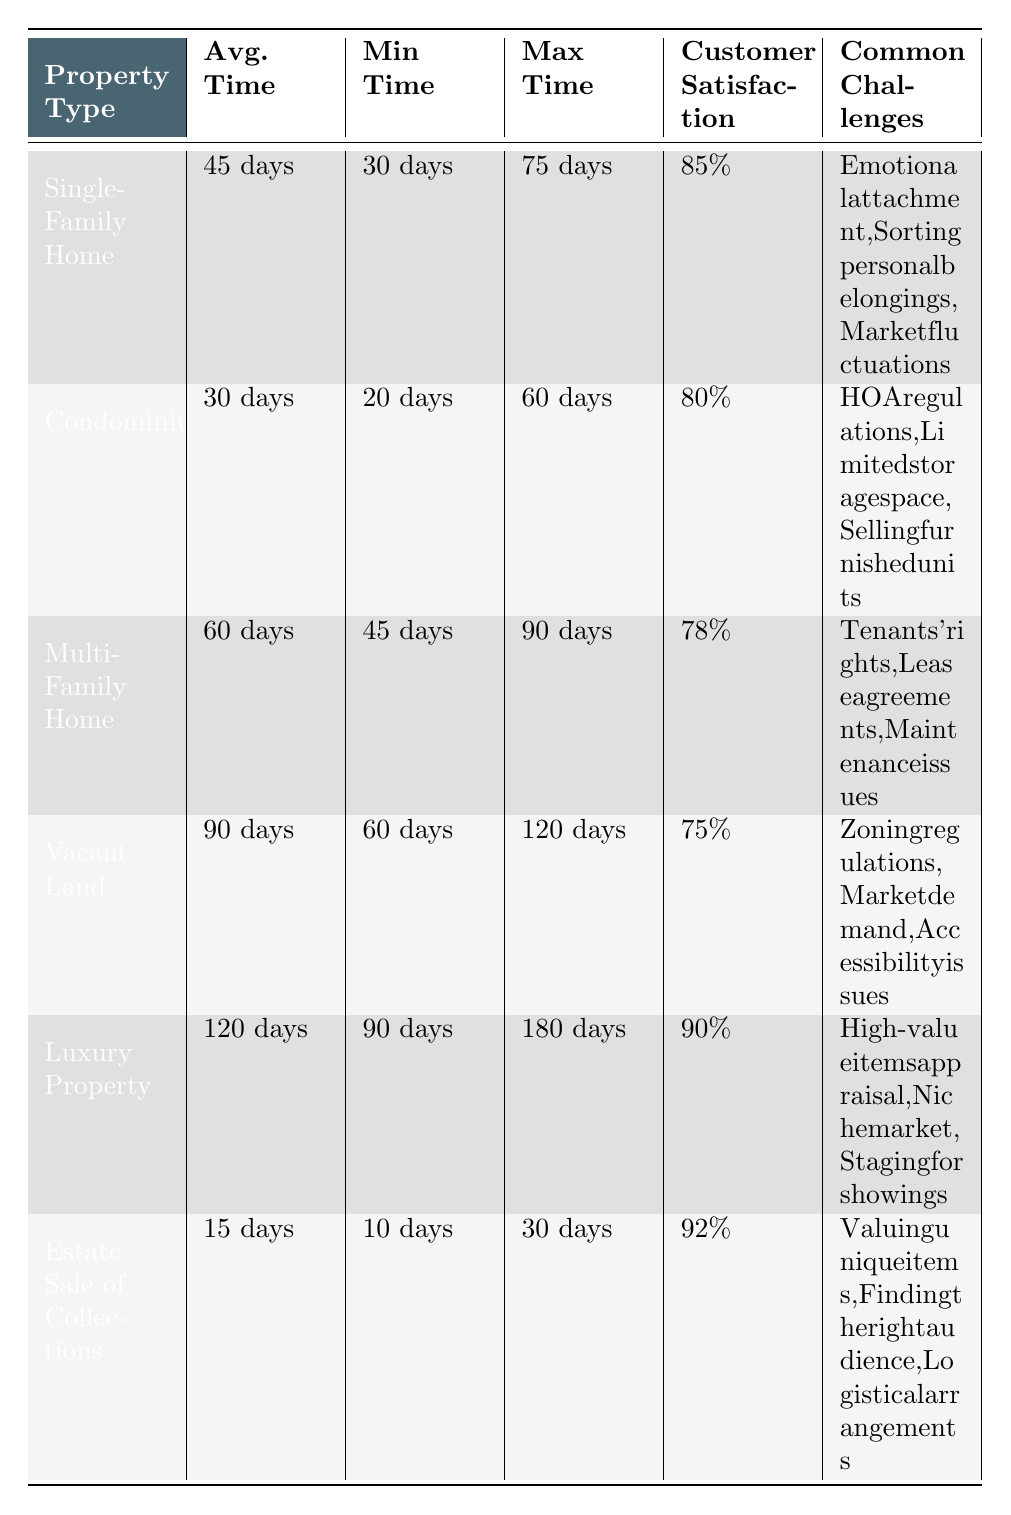What is the average time to complete an estate liquidation for a Single-Family Home? The table states that the average time to complete an estate liquidation for a Single-Family Home is explicitly listed as 45 days.
Answer: 45 days What is the customer satisfaction percentage for Vacant Land? According to the table, customer satisfaction for Vacant Land is indicated as 75%.
Answer: 75% Which property type has the longest average time to complete? The table shows that Luxury Property has the longest average time to complete at 120 days.
Answer: Luxury Property What is the minimum time to complete the estate liquidation of a Condominium? The table specifies that the minimum time for a Condominium is 20 days.
Answer: 20 days Is the average time for Estate Sale of Collections shorter than that for a Luxury Property? The average time for Estate Sale of Collections is 15 days, while for Luxury Property it is 120 days, so yes, it is shorter.
Answer: Yes What is the difference in average time to complete between Multi-Family Home and Single-Family Home? The average time for Multi-Family Homes is 60 days and for Single-Family Homes is 45 days. The difference is calculated as 60 - 45 = 15 days.
Answer: 15 days What are the common challenges faced in liquidating a Luxury Property? The table lists the common challenges for Luxury Property as high-value items appraisal, niche market, and staging for showings.
Answer: High-value items appraisal, niche market, staging for showings Which property type has the highest customer satisfaction rating? The table shows that Estate Sale of Collections has the highest customer satisfaction rating at 92%.
Answer: Estate Sale of Collections How do the average times to complete for Single-Family Home and Condominium compare in terms of their percentages? The average time for Single-Family Home is 45 days, and for Condominium, it's 30 days. We recognize that 30 days is 66.67% of 45 days, hence the Condominium is completed faster.
Answer: Condominium is faster by approximately 33.33% Which property types share the common challenge of market fluctuations? Only the Single-Family Home is listed with the common challenge of market fluctuations; no other type includes it.
Answer: Single-Family Home only 